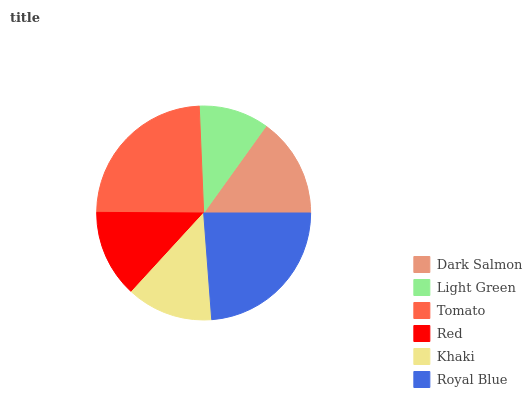Is Light Green the minimum?
Answer yes or no. Yes. Is Tomato the maximum?
Answer yes or no. Yes. Is Tomato the minimum?
Answer yes or no. No. Is Light Green the maximum?
Answer yes or no. No. Is Tomato greater than Light Green?
Answer yes or no. Yes. Is Light Green less than Tomato?
Answer yes or no. Yes. Is Light Green greater than Tomato?
Answer yes or no. No. Is Tomato less than Light Green?
Answer yes or no. No. Is Dark Salmon the high median?
Answer yes or no. Yes. Is Red the low median?
Answer yes or no. Yes. Is Red the high median?
Answer yes or no. No. Is Royal Blue the low median?
Answer yes or no. No. 